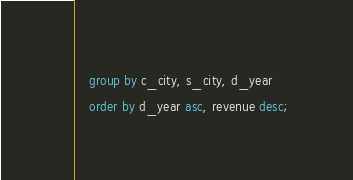<code> <loc_0><loc_0><loc_500><loc_500><_SQL_>	group by c_city, s_city, d_year
	order by d_year asc, revenue desc;
</code> 